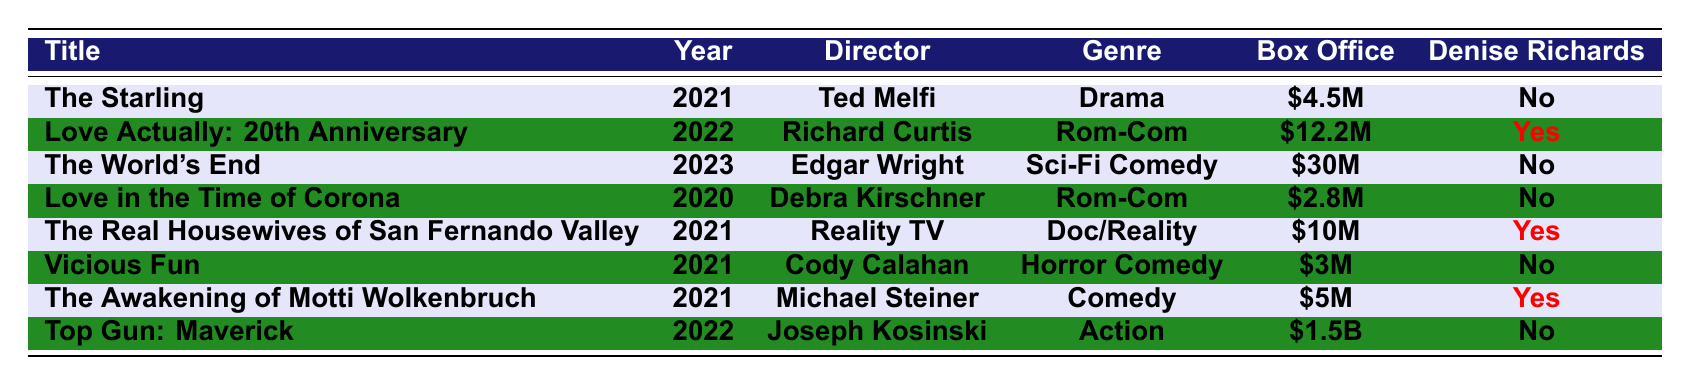What is the box office gross of "Top Gun: Maverick"? The table shows that "Top Gun: Maverick" has a box office gross of $1.5 billion.
Answer: $1.5 billion Which movie directed by Richard Curtis features Denise Richards? The table lists "Love Actually: 20th Anniversary" as directed by Richard Curtis and has Denise Richards credited as one of the starring actors.
Answer: Love Actually: 20th Anniversary What genre is the film "The Real Housewives of San Fernando Valley"? The table specifies that the genre of "The Real Housewives of San Fernando Valley" is Documentary/Reality.
Answer: Documentary/Reality Which 2021 film had the lowest box office gross? By comparing the box office grosses in the table, "Vicious Fun" has the lowest at $3 million.
Answer: $3 million Did any film starring Denise Richards gross more than $10 million? The table indicates that "Love Actually: 20th Anniversary" grossed $12.2 million, which is more than $10 million, and it features Denise Richards.
Answer: Yes How much more did "Top Gun: Maverick" earn than "The Starling"? "Top Gun: Maverick" earned $1.5 billion while "The Starling" earned $4.5 million. The difference is calculated as $1.5 billion - $4.5 million, which converts to $1,500 million - $4.5 million = $1,495.5 million.
Answer: $1,495.5 million Which movie released in 2021 starred Denise Richards and is classified as a comedy? The table lists "The Awakening of Motti Wolkenbruch," released in 2021, as a comedy that stars Denise Richards.
Answer: The Awakening of Motti Wolkenbruch What percentage of the total box office gross from the movies in this table does "Top Gun: Maverick" represent? First, we find the total box office gross: $1.5 billion + $4.5M + $12.2M + $30M + $2.8M + $10M + $3M + $5M = $1,500M + $4.5M + $12.2M + $30M + $2.8M + $10M + $3M + $5M = $1,564.5 million. Then, we calculate the percentage: ($1,500M / $1,564.5M) * 100 = approximately 95.90%.
Answer: Approximately 95.90% What is the total box office gross for the movies that feature Denise Richards? The box offices for films with Denise Richards are $12.2 million (Love Actually: 20th Anniversary), $10 million (The Real Housewives of San Fernando Valley), and $5 million (The Awakening of Motti Wolkenbruch), totaling $12.2M + $10M + $5M = $27.2 million.
Answer: $27.2 million How many movies in the table are categorized as "Romantic Comedy"? The table shows two movies classified as "Romantic Comedy": "Love Actually: 20th Anniversary" and "Love in the Time of Corona."
Answer: 2 